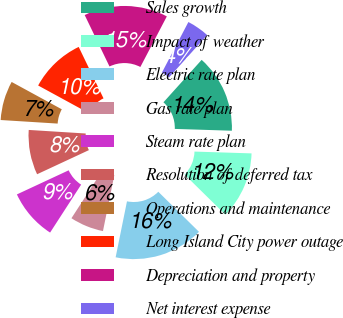Convert chart. <chart><loc_0><loc_0><loc_500><loc_500><pie_chart><fcel>Sales growth<fcel>Impact of weather<fcel>Electric rate plan<fcel>Gas rate plan<fcel>Steam rate plan<fcel>Resolution of deferred tax<fcel>Operations and maintenance<fcel>Long Island City power outage<fcel>Depreciation and property<fcel>Net interest expense<nl><fcel>13.84%<fcel>11.87%<fcel>15.81%<fcel>5.96%<fcel>8.92%<fcel>7.93%<fcel>6.95%<fcel>9.9%<fcel>14.83%<fcel>3.99%<nl></chart> 